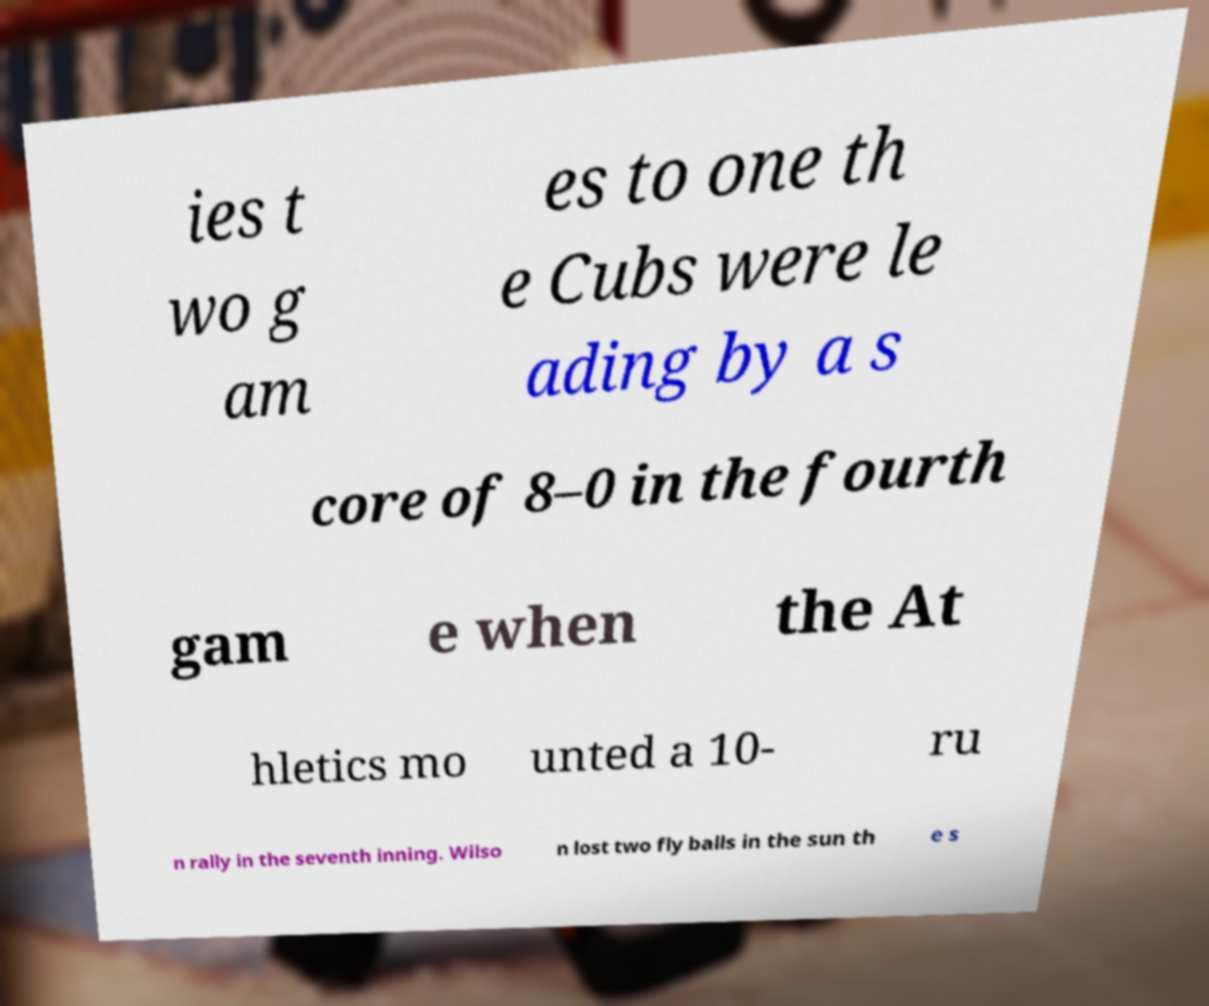Could you assist in decoding the text presented in this image and type it out clearly? ies t wo g am es to one th e Cubs were le ading by a s core of 8–0 in the fourth gam e when the At hletics mo unted a 10- ru n rally in the seventh inning. Wilso n lost two fly balls in the sun th e s 